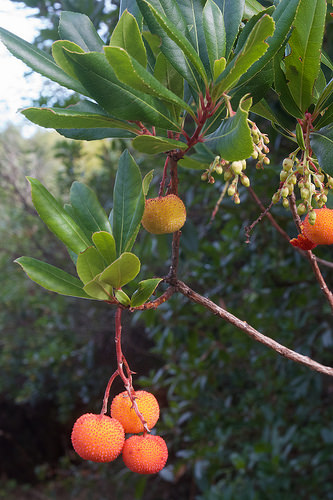<image>
Is the fruit on the branch? Yes. Looking at the image, I can see the fruit is positioned on top of the branch, with the branch providing support. 